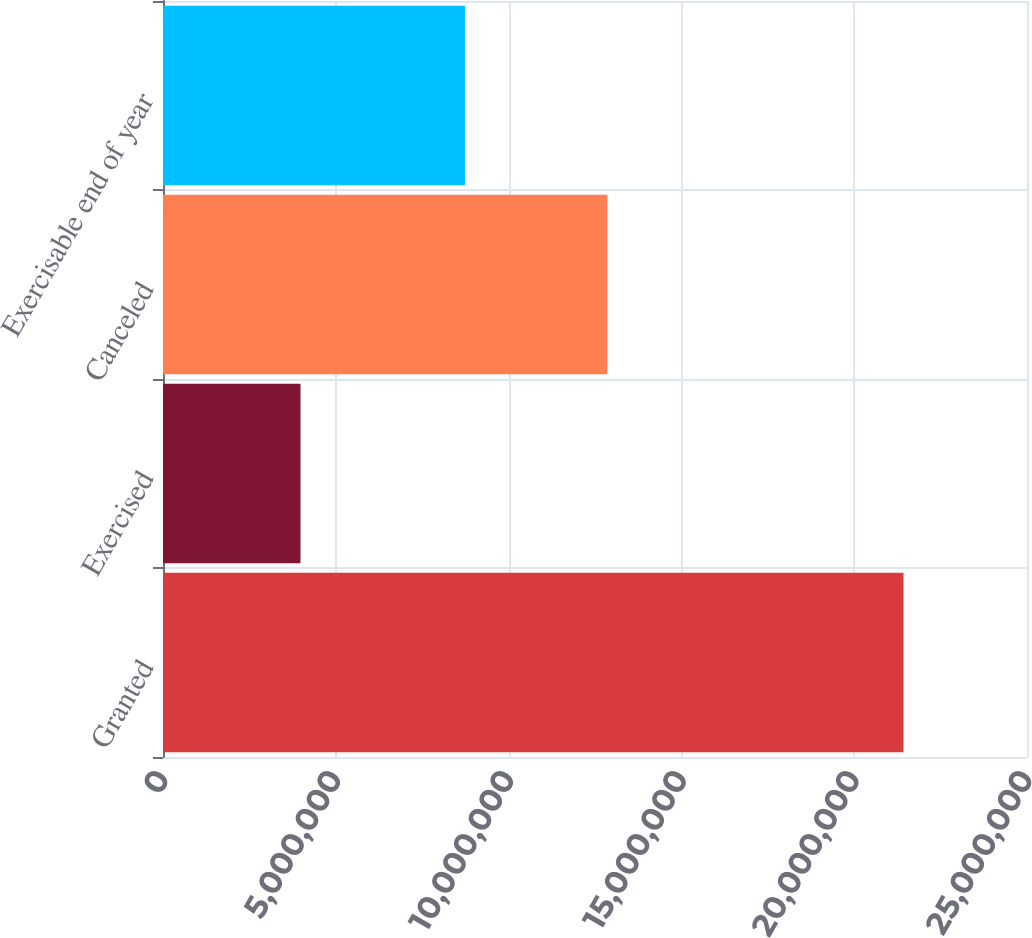Convert chart to OTSL. <chart><loc_0><loc_0><loc_500><loc_500><bar_chart><fcel>Granted<fcel>Exercised<fcel>Canceled<fcel>Exercisable end of year<nl><fcel>2.14267e+07<fcel>3.97795e+06<fcel>1.28596e+07<fcel>8.73664e+06<nl></chart> 